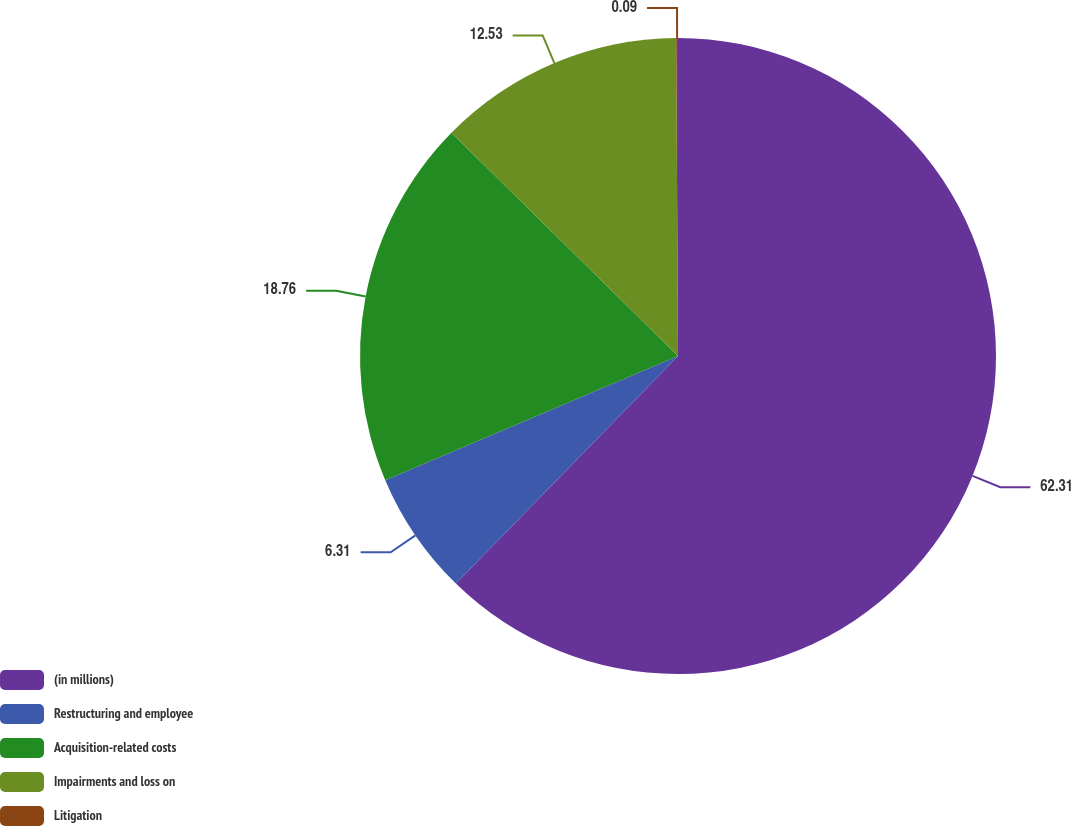<chart> <loc_0><loc_0><loc_500><loc_500><pie_chart><fcel>(in millions)<fcel>Restructuring and employee<fcel>Acquisition-related costs<fcel>Impairments and loss on<fcel>Litigation<nl><fcel>62.3%<fcel>6.31%<fcel>18.76%<fcel>12.53%<fcel>0.09%<nl></chart> 